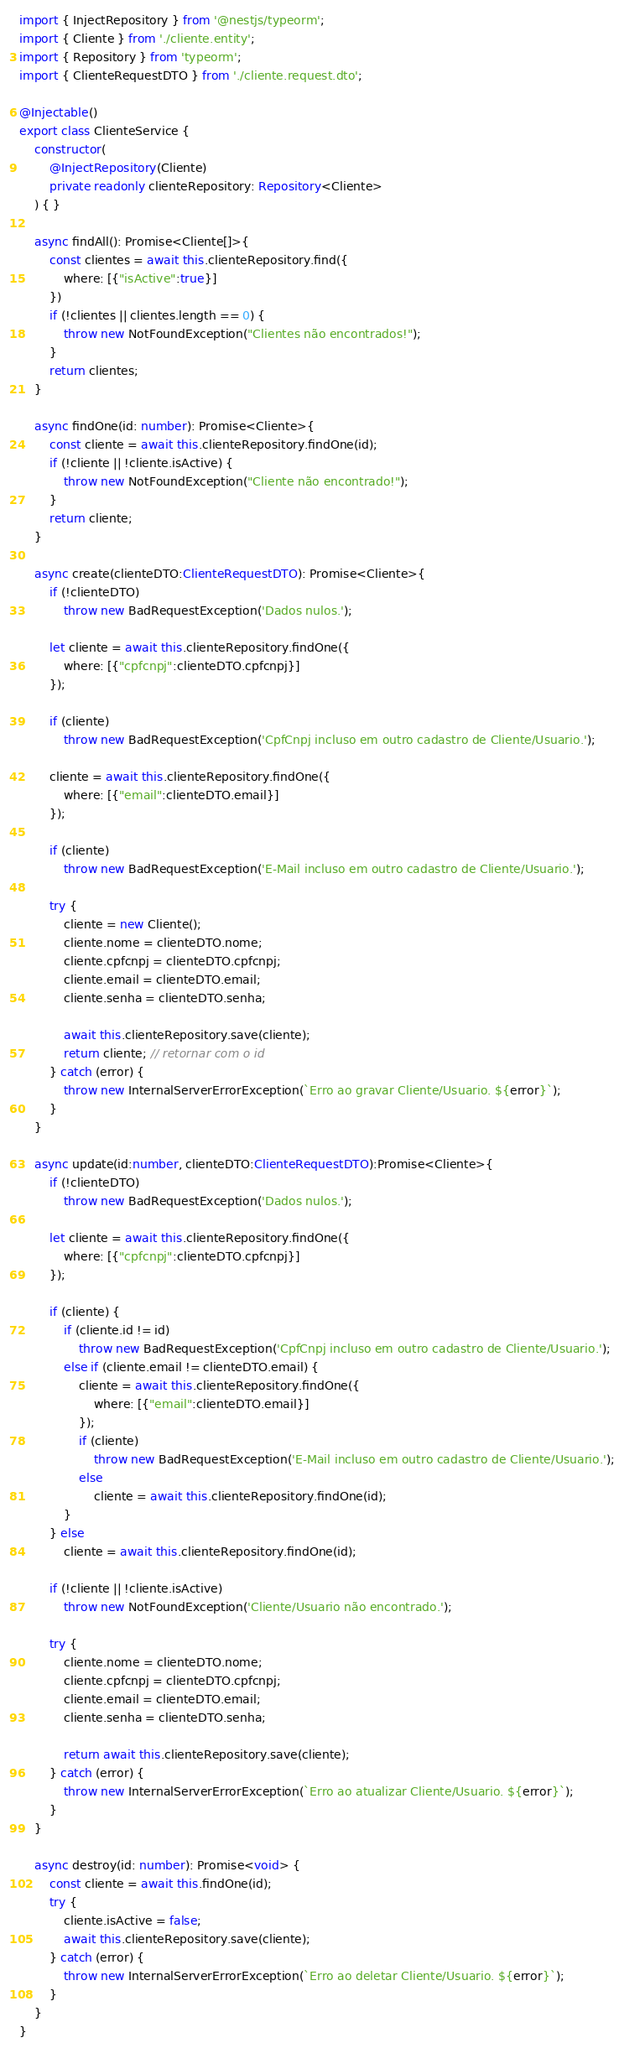<code> <loc_0><loc_0><loc_500><loc_500><_TypeScript_>import { InjectRepository } from '@nestjs/typeorm';
import { Cliente } from './cliente.entity';
import { Repository } from 'typeorm';
import { ClienteRequestDTO } from './cliente.request.dto';

@Injectable()
export class ClienteService {
    constructor(
        @InjectRepository(Cliente)
        private readonly clienteRepository: Repository<Cliente>
    ) { }

    async findAll(): Promise<Cliente[]>{
        const clientes = await this.clienteRepository.find({
            where: [{"isActive":true}]
        })
        if (!clientes || clientes.length == 0) {
            throw new NotFoundException("Clientes não encontrados!");
        }
        return clientes;
    }

    async findOne(id: number): Promise<Cliente>{
        const cliente = await this.clienteRepository.findOne(id);
        if (!cliente || !cliente.isActive) {
            throw new NotFoundException("Cliente não encontrado!");
        }
        return cliente;
    }

    async create(clienteDTO:ClienteRequestDTO): Promise<Cliente>{
        if (!clienteDTO)
            throw new BadRequestException('Dados nulos.');
        
        let cliente = await this.clienteRepository.findOne({
            where: [{"cpfcnpj":clienteDTO.cpfcnpj}]
        });
        
        if (cliente)
            throw new BadRequestException('CpfCnpj incluso em outro cadastro de Cliente/Usuario.');

        cliente = await this.clienteRepository.findOne({
            where: [{"email":clienteDTO.email}]
        });

        if (cliente)
            throw new BadRequestException('E-Mail incluso em outro cadastro de Cliente/Usuario.');
       
        try {
            cliente = new Cliente();
            cliente.nome = clienteDTO.nome;
            cliente.cpfcnpj = clienteDTO.cpfcnpj;
            cliente.email = clienteDTO.email;
            cliente.senha = clienteDTO.senha;
        
            await this.clienteRepository.save(cliente);
            return cliente; // retornar com o id
        } catch (error) {
            throw new InternalServerErrorException(`Erro ao gravar Cliente/Usuario. ${error}`);
        }
    }

    async update(id:number, clienteDTO:ClienteRequestDTO):Promise<Cliente>{
        if (!clienteDTO)
            throw new BadRequestException('Dados nulos.');
                
        let cliente = await this.clienteRepository.findOne({
            where: [{"cpfcnpj":clienteDTO.cpfcnpj}]
        });
        
        if (cliente) {
            if (cliente.id != id)
                throw new BadRequestException('CpfCnpj incluso em outro cadastro de Cliente/Usuario.');
            else if (cliente.email != clienteDTO.email) {
                cliente = await this.clienteRepository.findOne({
                    where: [{"email":clienteDTO.email}]
                });
                if (cliente)
                    throw new BadRequestException('E-Mail incluso em outro cadastro de Cliente/Usuario.');
                else 
                    cliente = await this.clienteRepository.findOne(id);
            }
        } else 
            cliente = await this.clienteRepository.findOne(id);

        if (!cliente || !cliente.isActive)
            throw new NotFoundException('Cliente/Usuario não encontrado.');

        try {
            cliente.nome = clienteDTO.nome;
            cliente.cpfcnpj = clienteDTO.cpfcnpj;
            cliente.email = clienteDTO.email;
            cliente.senha = clienteDTO.senha;
        
            return await this.clienteRepository.save(cliente);
        } catch (error) {
            throw new InternalServerErrorException(`Erro ao atualizar Cliente/Usuario. ${error}`);
        }
    }

    async destroy(id: number): Promise<void> {
        const cliente = await this.findOne(id);
        try {
            cliente.isActive = false;
            await this.clienteRepository.save(cliente);
        } catch (error) {
            throw new InternalServerErrorException(`Erro ao deletar Cliente/Usuario. ${error}`);
        }
    }
}
</code> 